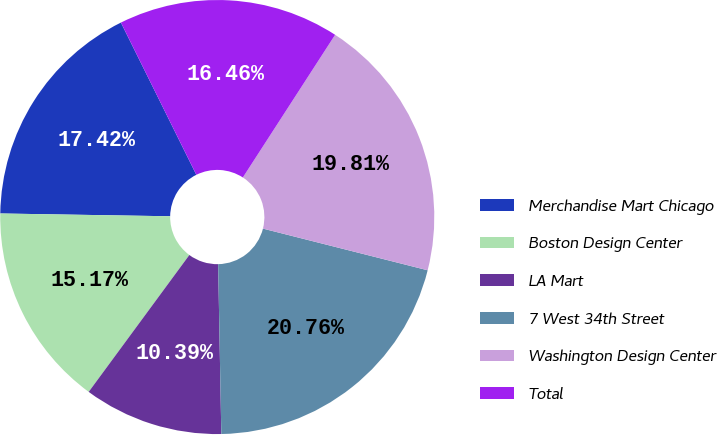Convert chart. <chart><loc_0><loc_0><loc_500><loc_500><pie_chart><fcel>Merchandise Mart Chicago<fcel>Boston Design Center<fcel>LA Mart<fcel>7 West 34th Street<fcel>Washington Design Center<fcel>Total<nl><fcel>17.42%<fcel>15.17%<fcel>10.39%<fcel>20.76%<fcel>19.81%<fcel>16.46%<nl></chart> 